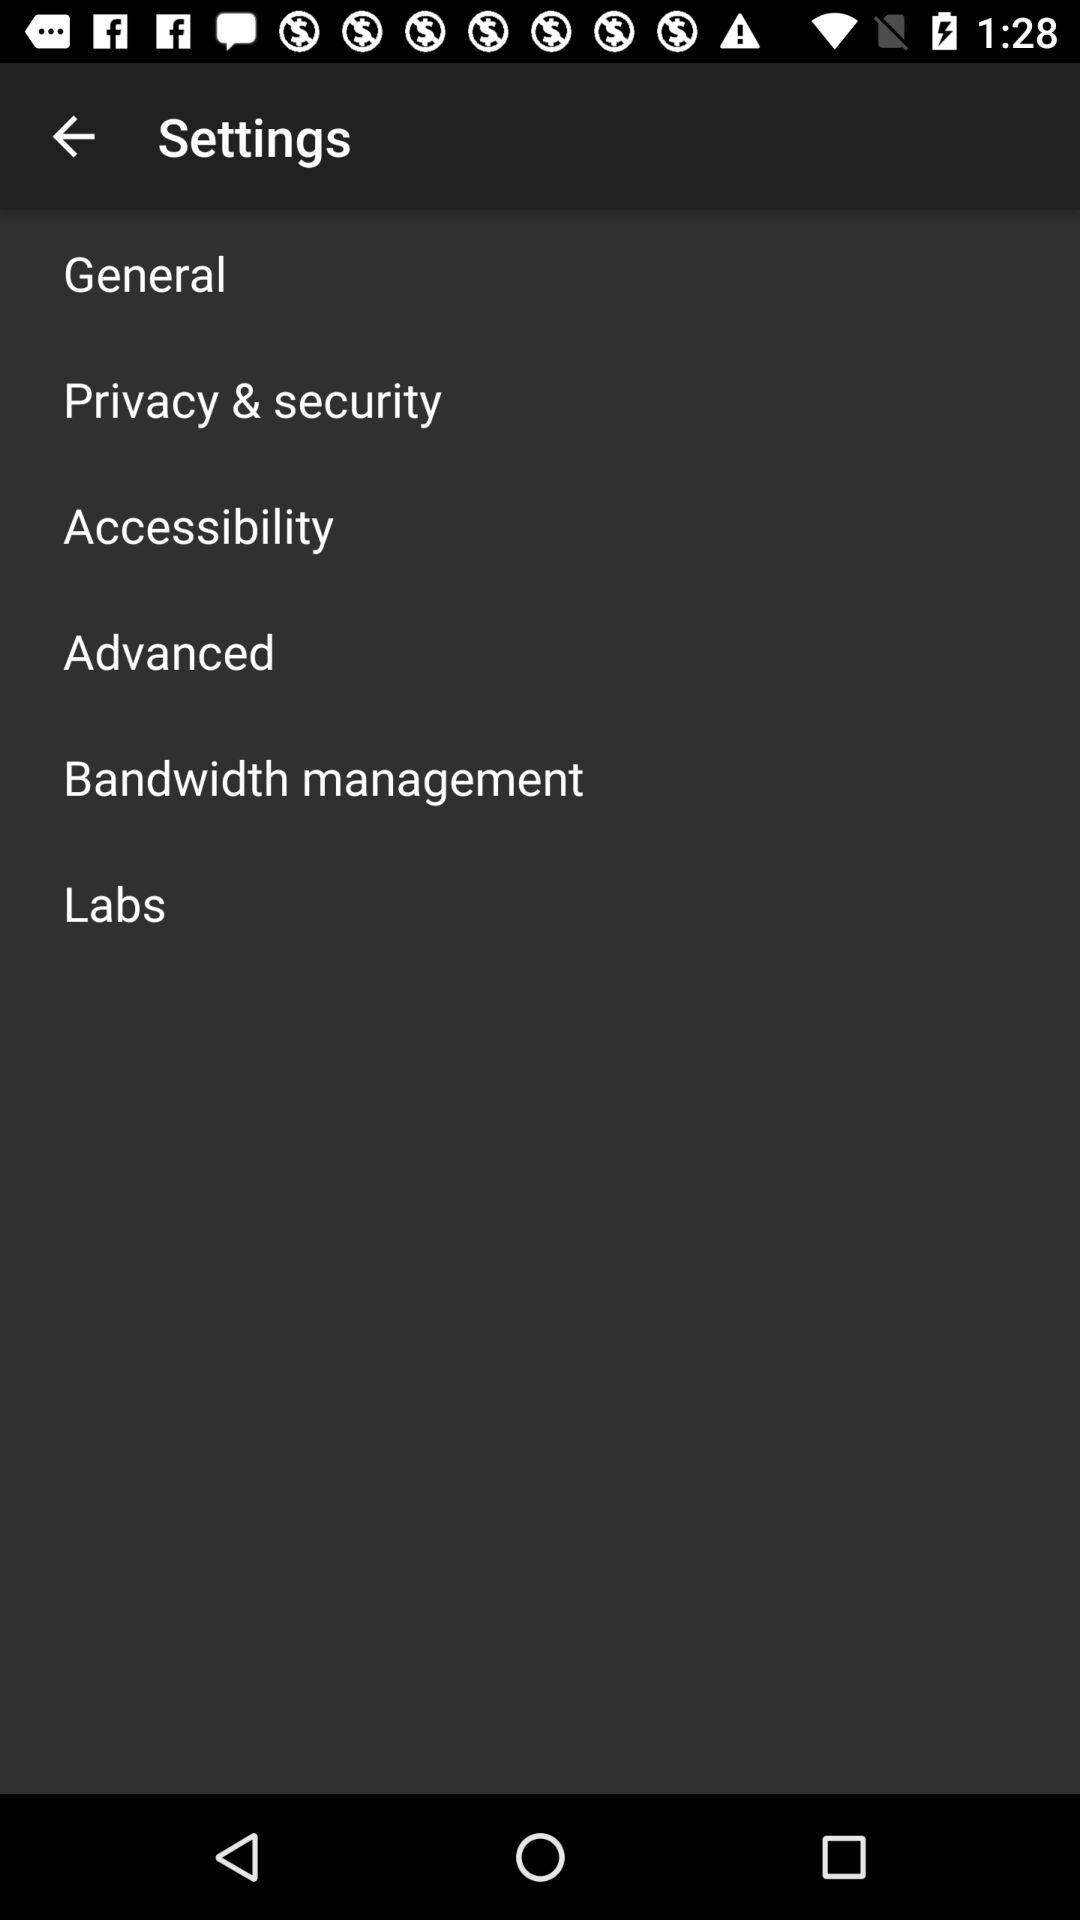How many items are in the settings menu?
Answer the question using a single word or phrase. 6 